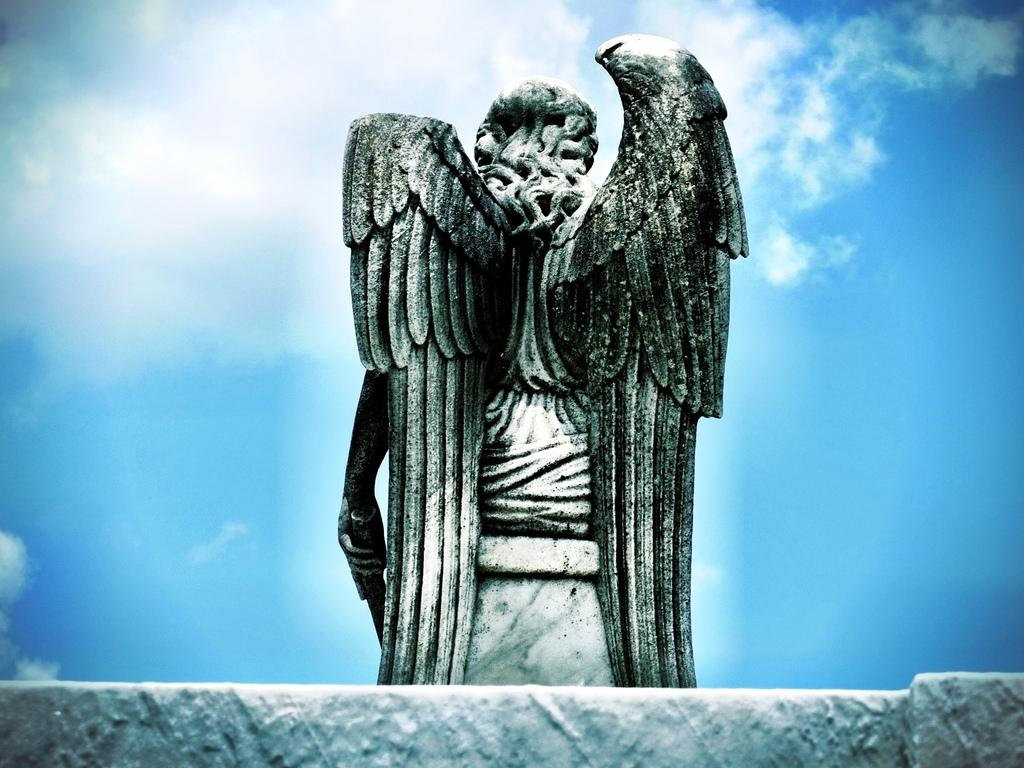What is the main subject in the image? There is a statue of an angel in the image. Where is the statue located in the image? The statue is in the front of the image. What is visible in the background of the image? There is a sky visible in the image. What can be seen in the sky in the image? The sky contains clouds in the image. What grade does the statue of the angel receive for its form in the image? There is no grade given to the statue of the angel in the image, as it is not a subject being evaluated or graded. 